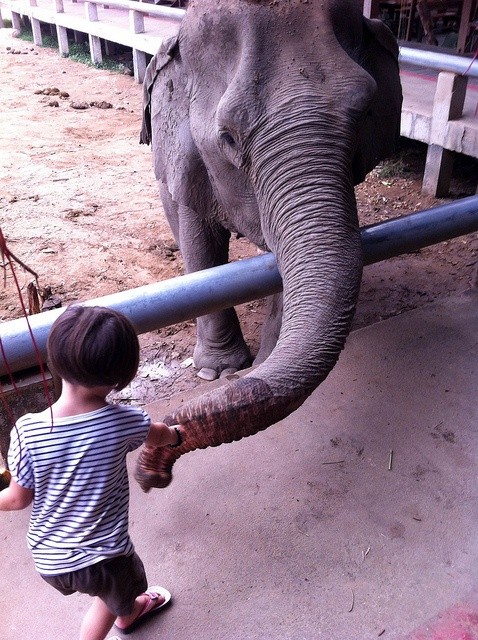Describe the objects in this image and their specific colors. I can see elephant in white, black, purple, darkgray, and gray tones and people in white, black, lavender, and purple tones in this image. 